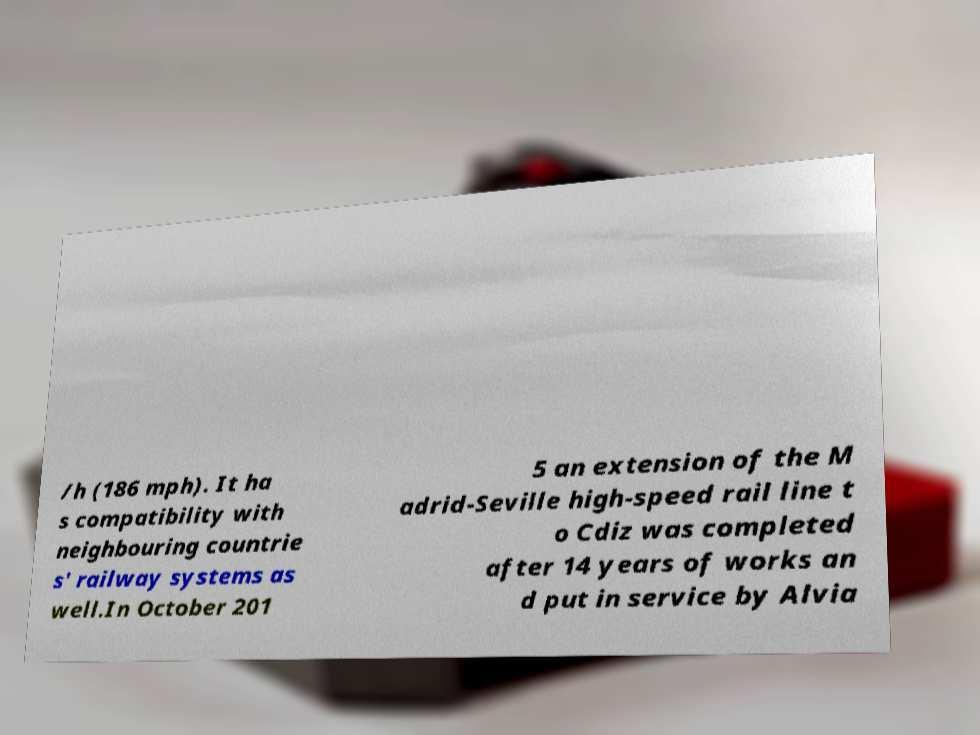Can you accurately transcribe the text from the provided image for me? /h (186 mph). It ha s compatibility with neighbouring countrie s' railway systems as well.In October 201 5 an extension of the M adrid-Seville high-speed rail line t o Cdiz was completed after 14 years of works an d put in service by Alvia 